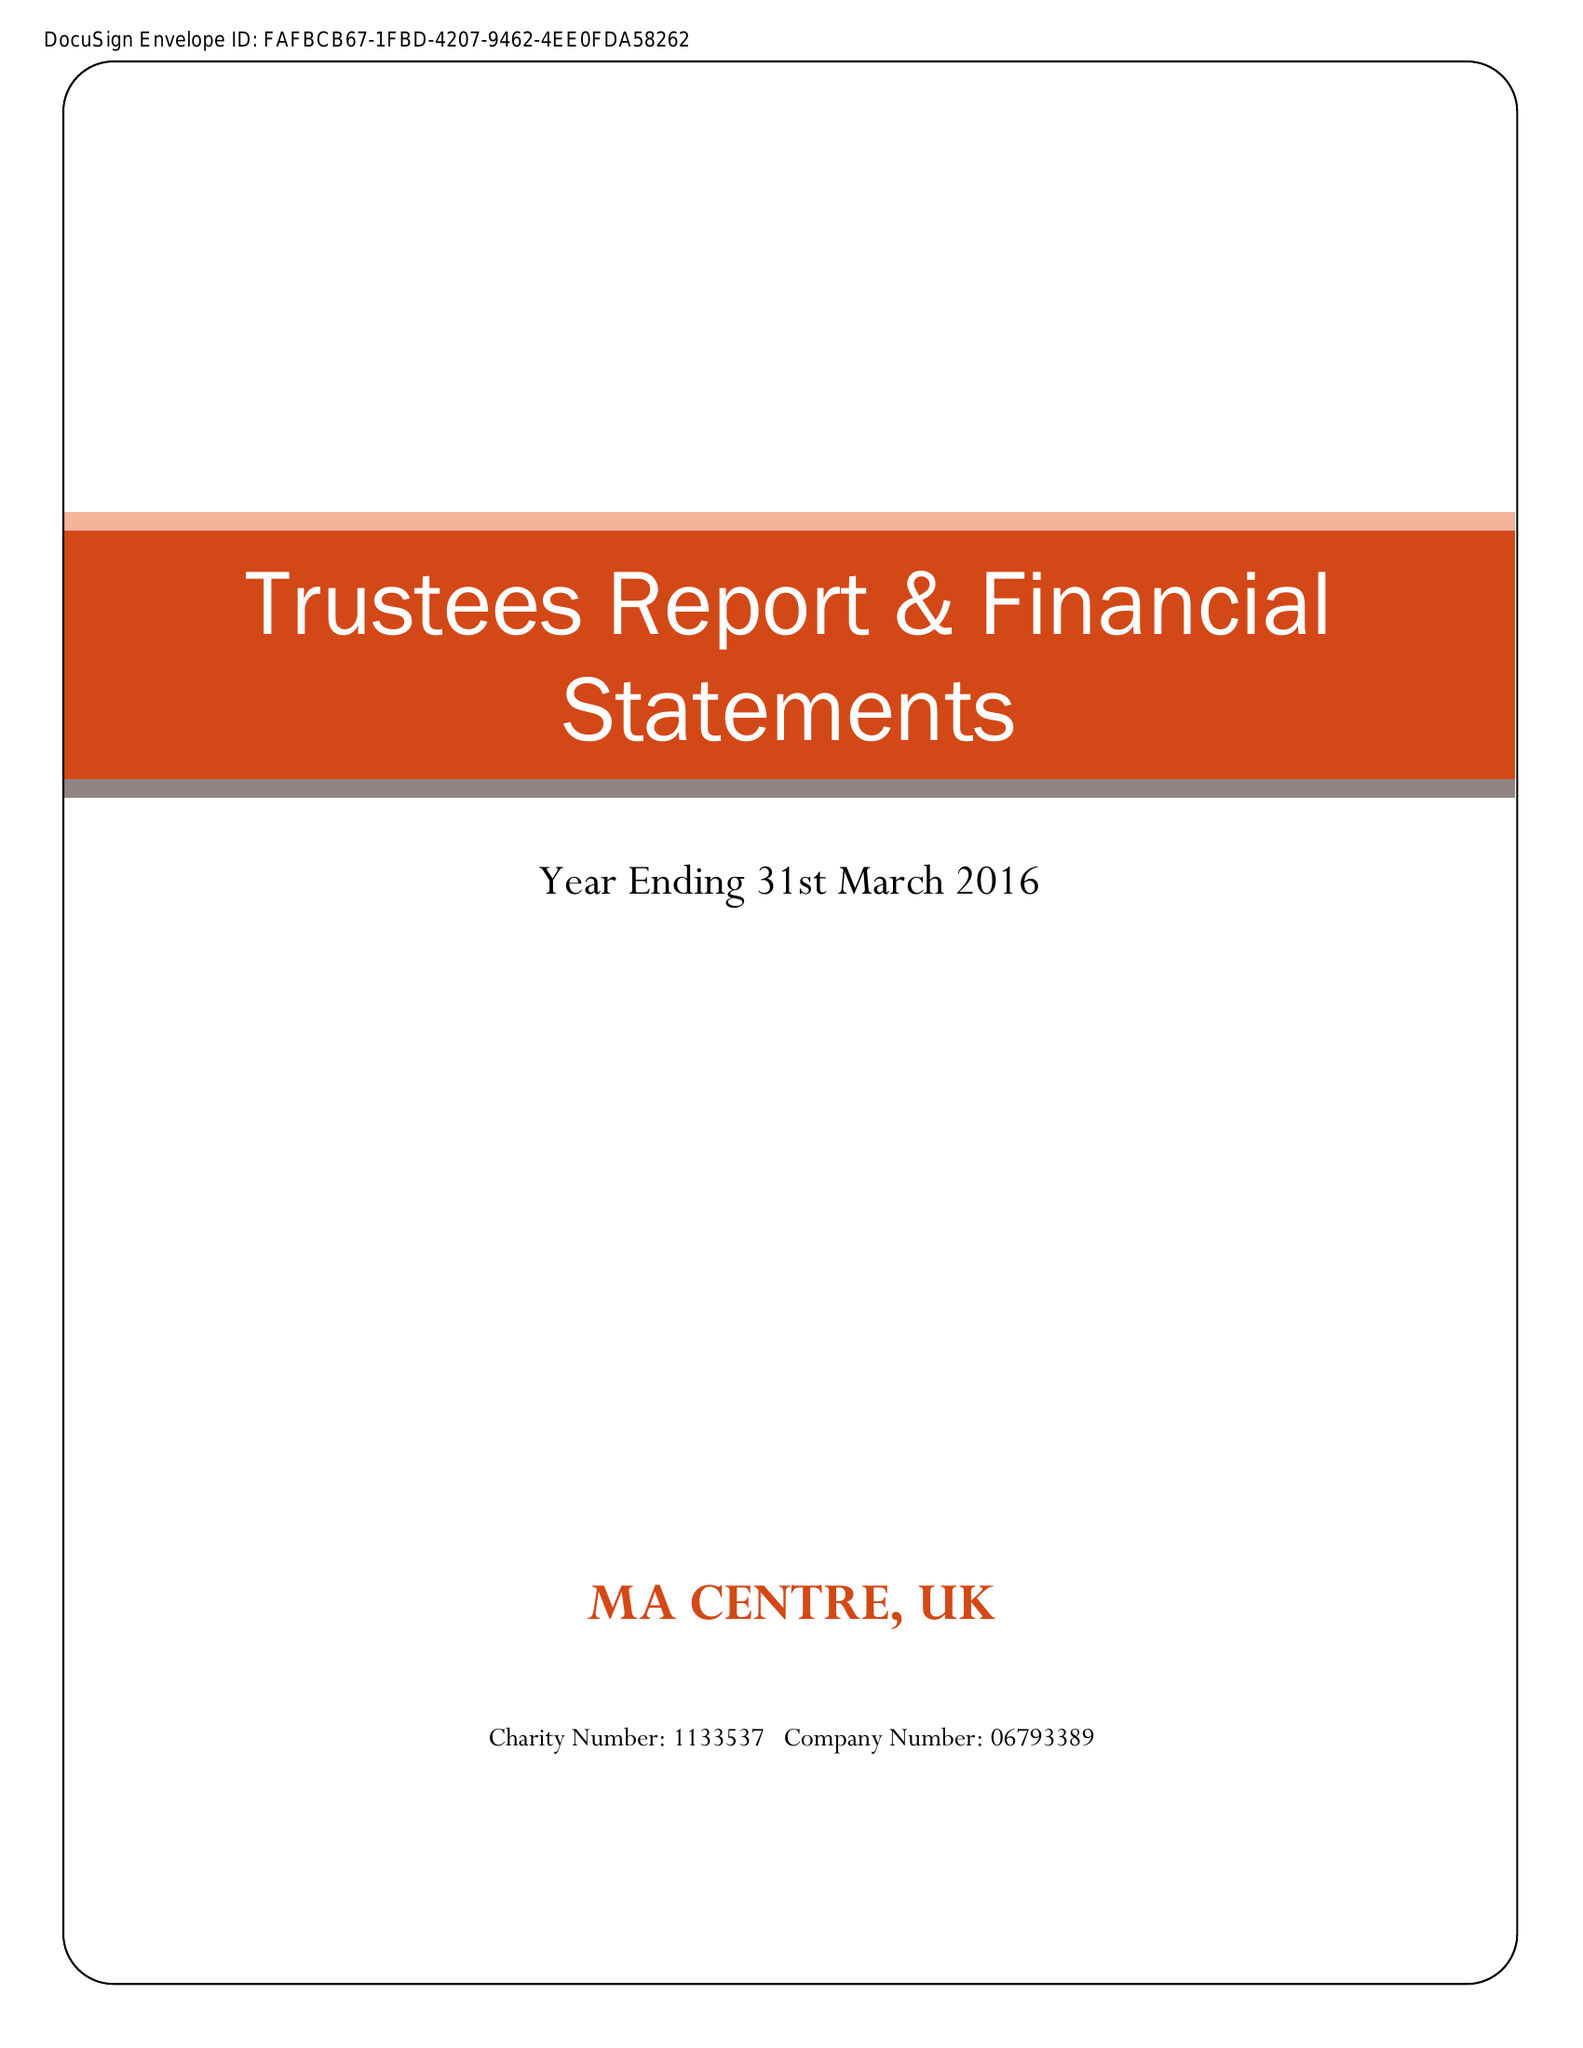What is the value for the address__street_line?
Answer the question using a single word or phrase. 40A LETCHWORTH DRIVE 